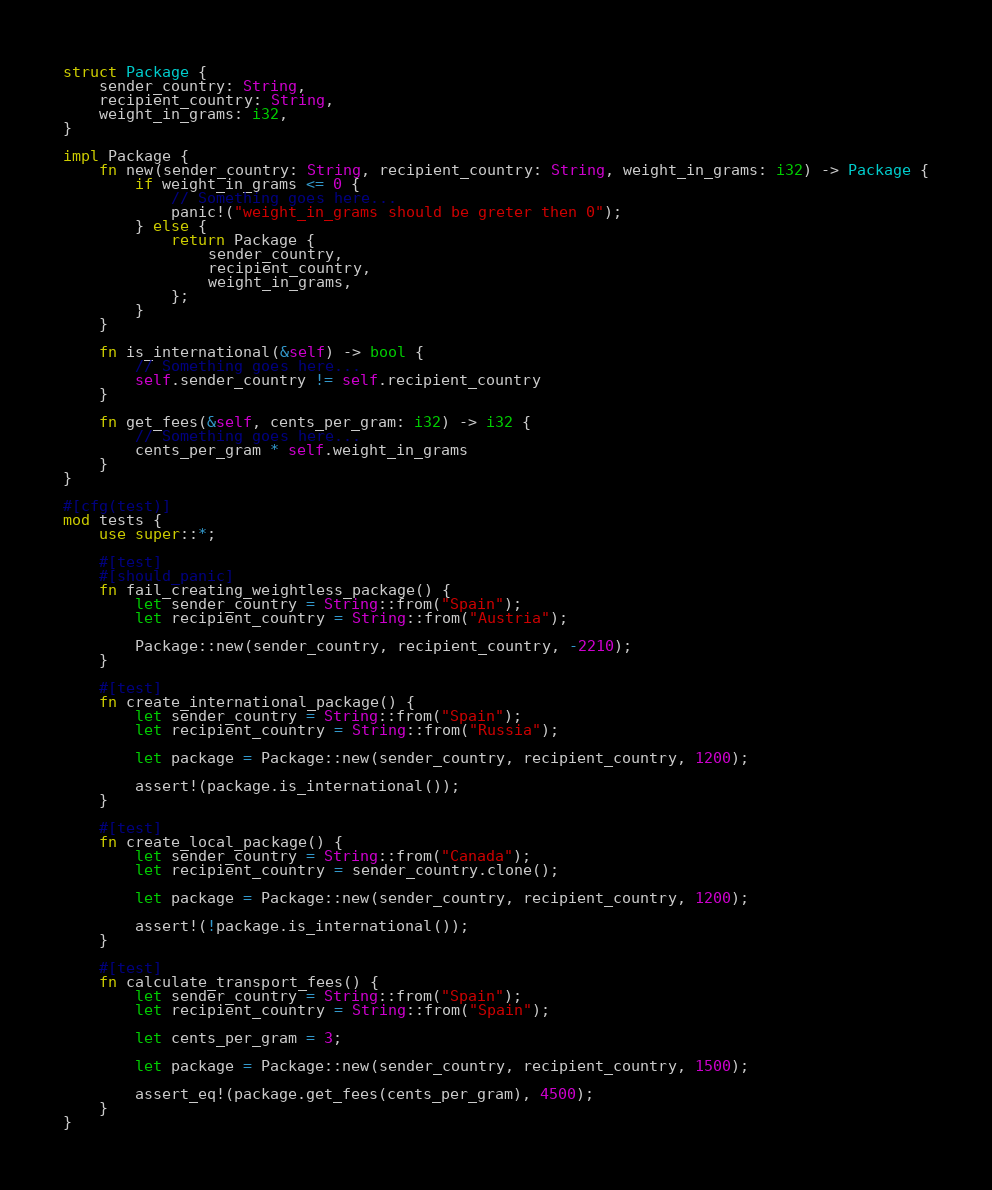Convert code to text. <code><loc_0><loc_0><loc_500><loc_500><_Rust_>struct Package {
    sender_country: String,
    recipient_country: String,
    weight_in_grams: i32,
}

impl Package {
    fn new(sender_country: String, recipient_country: String, weight_in_grams: i32) -> Package {
        if weight_in_grams <= 0 {
            // Something goes here...
            panic!("weight_in_grams should be greter then 0");
        } else {
            return Package {
                sender_country,
                recipient_country,
                weight_in_grams,
            };
        }
    }

    fn is_international(&self) -> bool {
        // Something goes here...
        self.sender_country != self.recipient_country
    }

    fn get_fees(&self, cents_per_gram: i32) -> i32 {
        // Something goes here...
        cents_per_gram * self.weight_in_grams
    }
}

#[cfg(test)]
mod tests {
    use super::*;

    #[test]
    #[should_panic]
    fn fail_creating_weightless_package() {
        let sender_country = String::from("Spain");
        let recipient_country = String::from("Austria");

        Package::new(sender_country, recipient_country, -2210);
    }

    #[test]
    fn create_international_package() {
        let sender_country = String::from("Spain");
        let recipient_country = String::from("Russia");

        let package = Package::new(sender_country, recipient_country, 1200);

        assert!(package.is_international());
    }

    #[test]
    fn create_local_package() {
        let sender_country = String::from("Canada");
        let recipient_country = sender_country.clone();

        let package = Package::new(sender_country, recipient_country, 1200);

        assert!(!package.is_international());
    }

    #[test]
    fn calculate_transport_fees() {
        let sender_country = String::from("Spain");
        let recipient_country = String::from("Spain");

        let cents_per_gram = 3;

        let package = Package::new(sender_country, recipient_country, 1500);

        assert_eq!(package.get_fees(cents_per_gram), 4500);
    }
}
</code> 